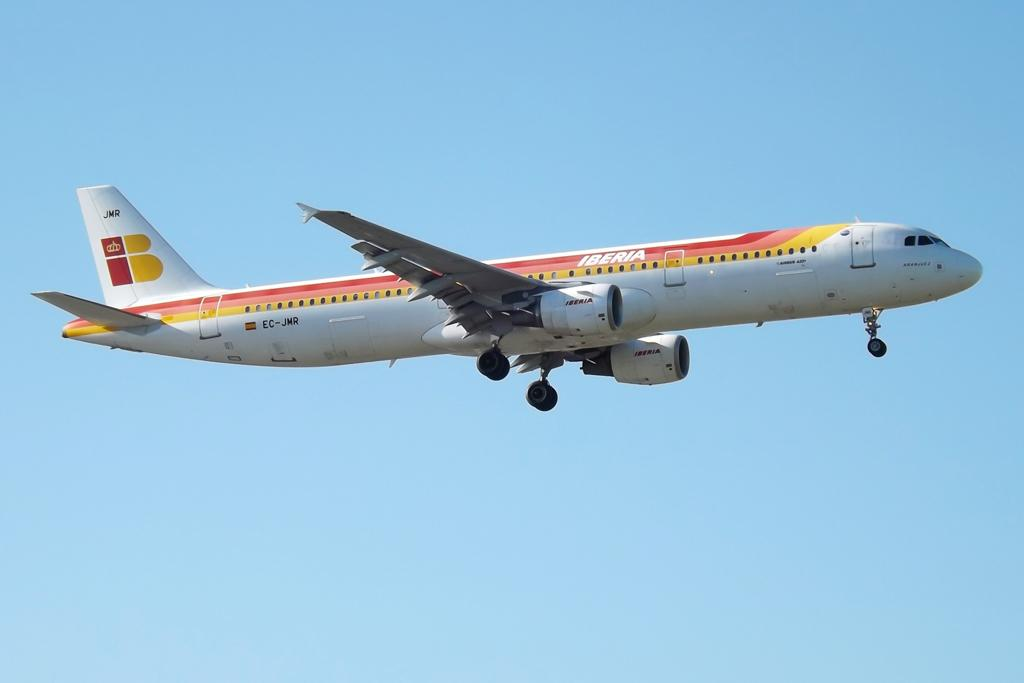<image>
Give a short and clear explanation of the subsequent image. an airplane flying in the sky called iberia 